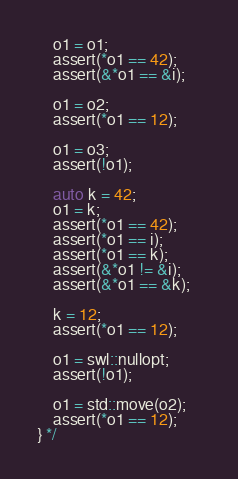<code> <loc_0><loc_0><loc_500><loc_500><_C++_>    o1 = o1;
    assert(*o1 == 42);
    assert(&*o1 == &i);    

    o1 = o2;
    assert(*o1 == 12);

    o1 = o3;
    assert(!o1);

    auto k = 42;
    o1 = k;
    assert(*o1 == 42);
    assert(*o1 == i);
    assert(*o1 == k);        
    assert(&*o1 != &i);
    assert(&*o1 == &k);

    k = 12;
    assert(*o1 == 12);

    o1 = swl::nullopt;
    assert(!o1);

    o1 = std::move(o2);
    assert(*o1 == 12);
} */ 
</code> 